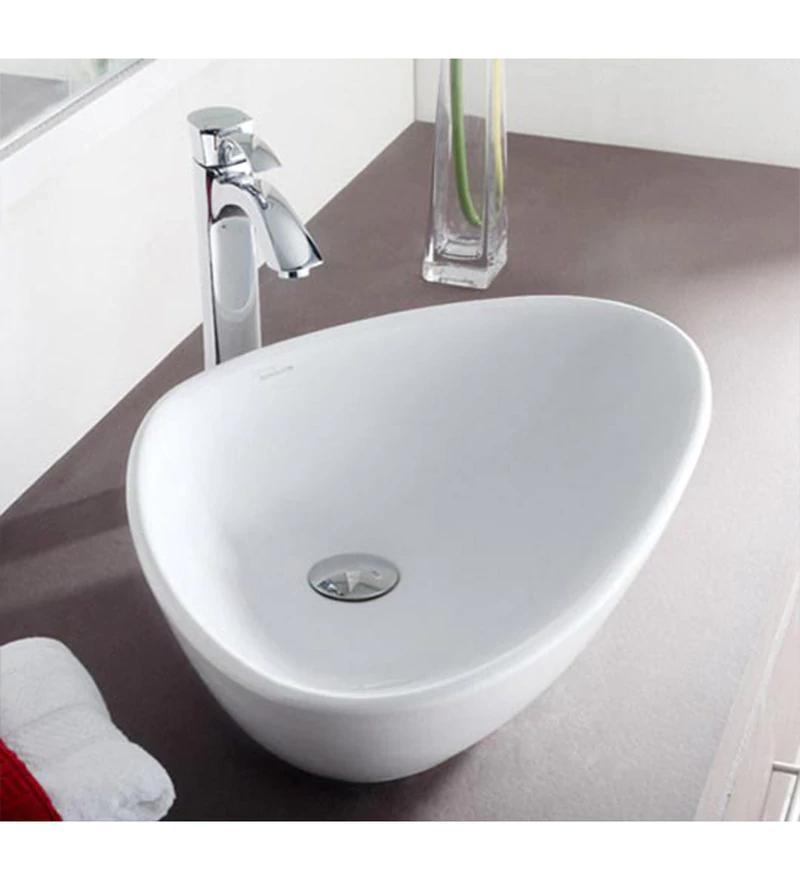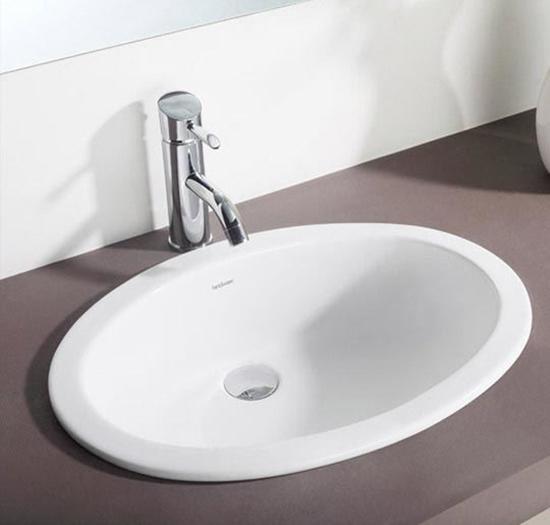The first image is the image on the left, the second image is the image on the right. Evaluate the accuracy of this statement regarding the images: "In one of the images, there is a white vase with yellow flowers in it". Is it true? Answer yes or no. No. 